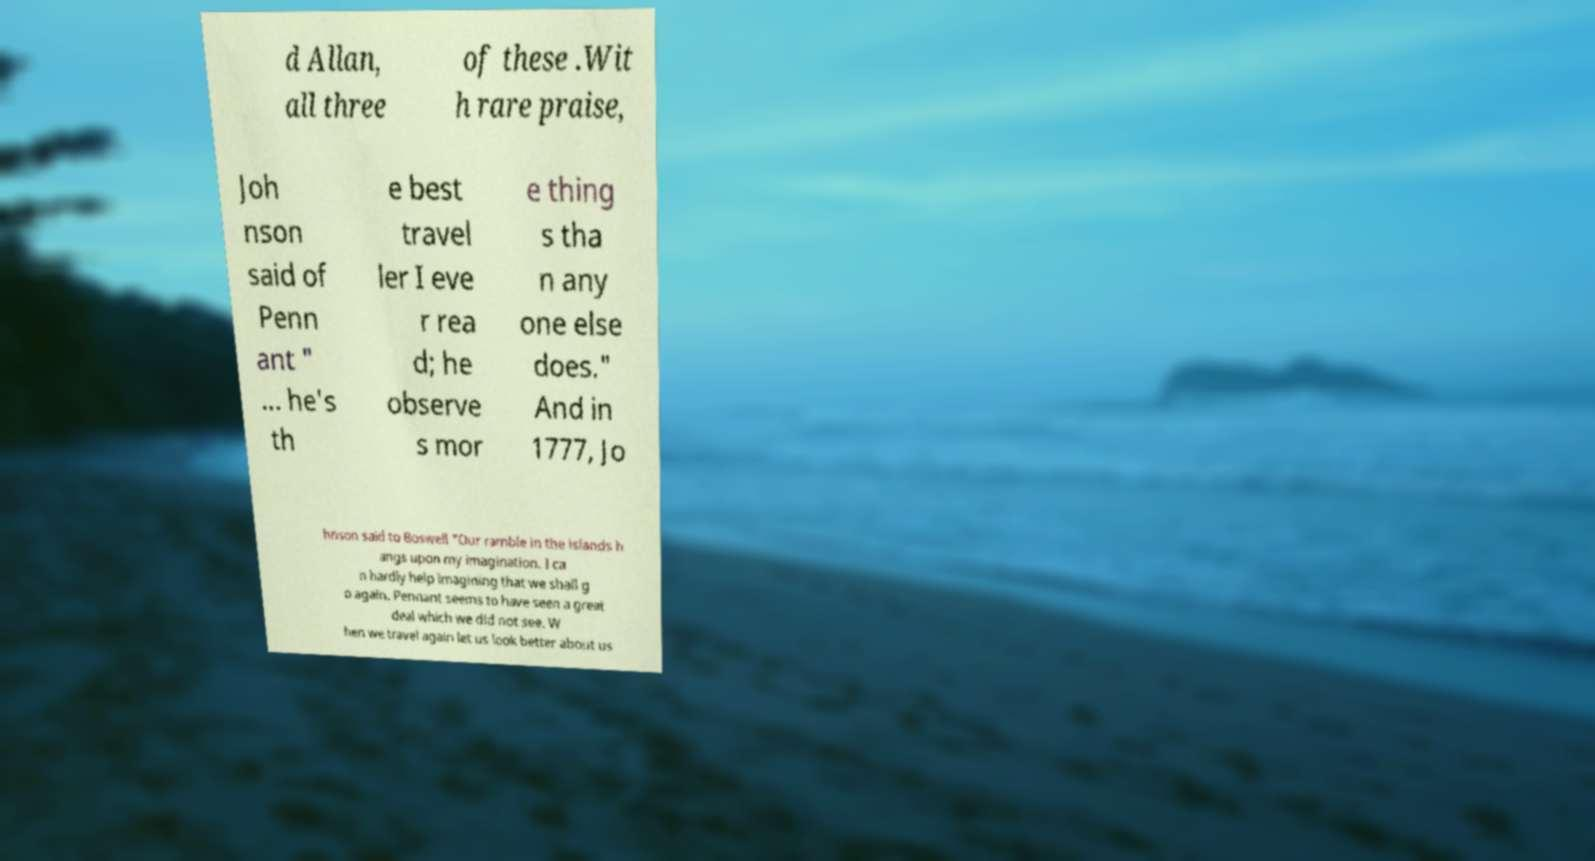Can you read and provide the text displayed in the image?This photo seems to have some interesting text. Can you extract and type it out for me? d Allan, all three of these .Wit h rare praise, Joh nson said of Penn ant " ... he's th e best travel ler I eve r rea d; he observe s mor e thing s tha n any one else does." And in 1777, Jo hnson said to Boswell "Our ramble in the islands h angs upon my imagination. I ca n hardly help imagining that we shall g o again. Pennant seems to have seen a great deal which we did not see. W hen we travel again let us look better about us 